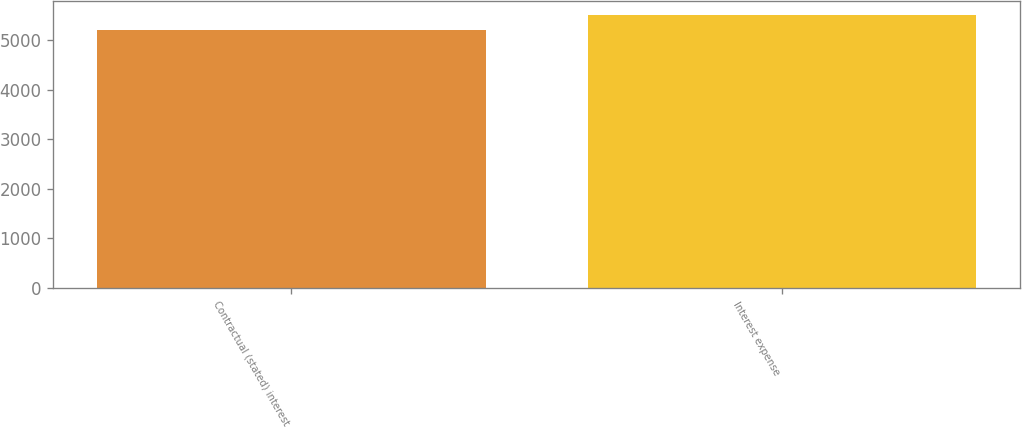Convert chart to OTSL. <chart><loc_0><loc_0><loc_500><loc_500><bar_chart><fcel>Contractual (stated) interest<fcel>Interest expense<nl><fcel>5209<fcel>5510<nl></chart> 